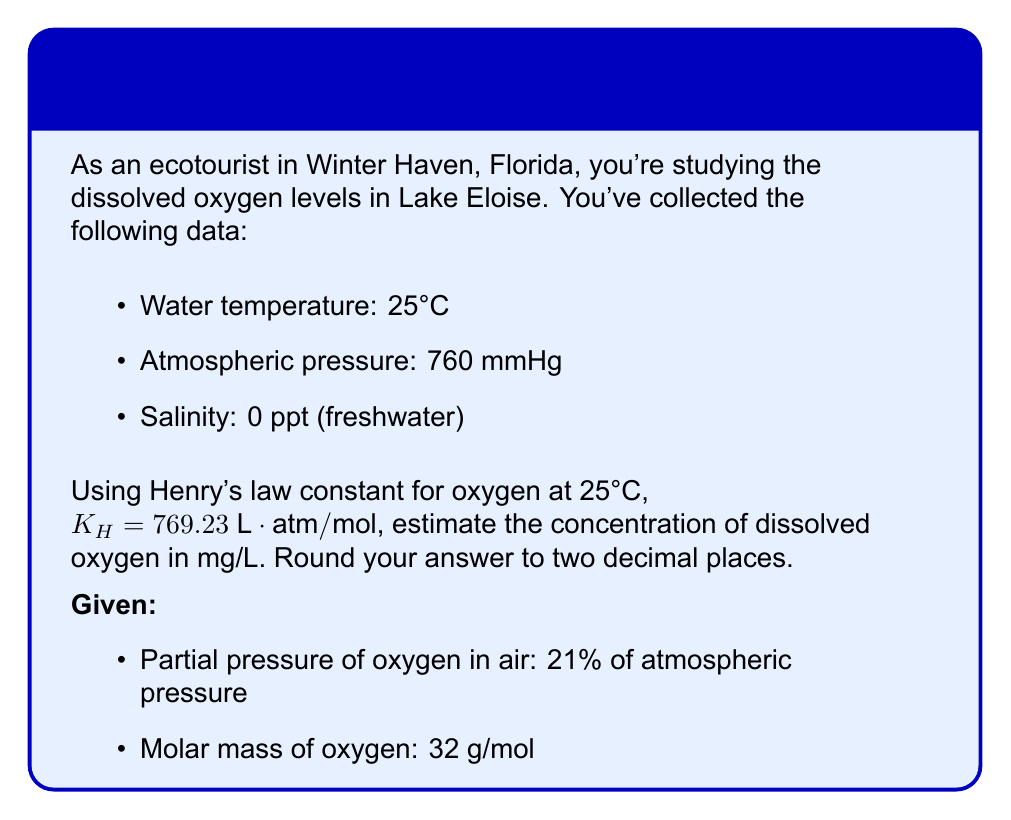Show me your answer to this math problem. Let's approach this step-by-step:

1) First, calculate the partial pressure of oxygen:
   $$P_{O_2} = 0.21 \times 760 \text{ mmHg} = 159.6 \text{ mmHg}$$

2) Convert mmHg to atm:
   $$P_{O_2} = 159.6 \text{ mmHg} \times \frac{1 \text{ atm}}{760 \text{ mmHg}} = 0.21 \text{ atm}$$

3) Use Henry's law to find the concentration in mol/L:
   $$C = \frac{P_{O_2}}{K_H} = \frac{0.21 \text{ atm}}{769.23 \text{ L}\cdot\text{atm}/\text{mol}} = 2.73 \times 10^{-4} \text{ mol/L}$$

4) Convert mol/L to mg/L:
   $$\text{Concentration} = 2.73 \times 10^{-4} \text{ mol/L} \times 32000 \text{ mg/mol} = 8.736 \text{ mg/L}$$

5) Round to two decimal places:
   $$\text{Concentration} \approx 8.74 \text{ mg/L}$$
Answer: 8.74 mg/L 